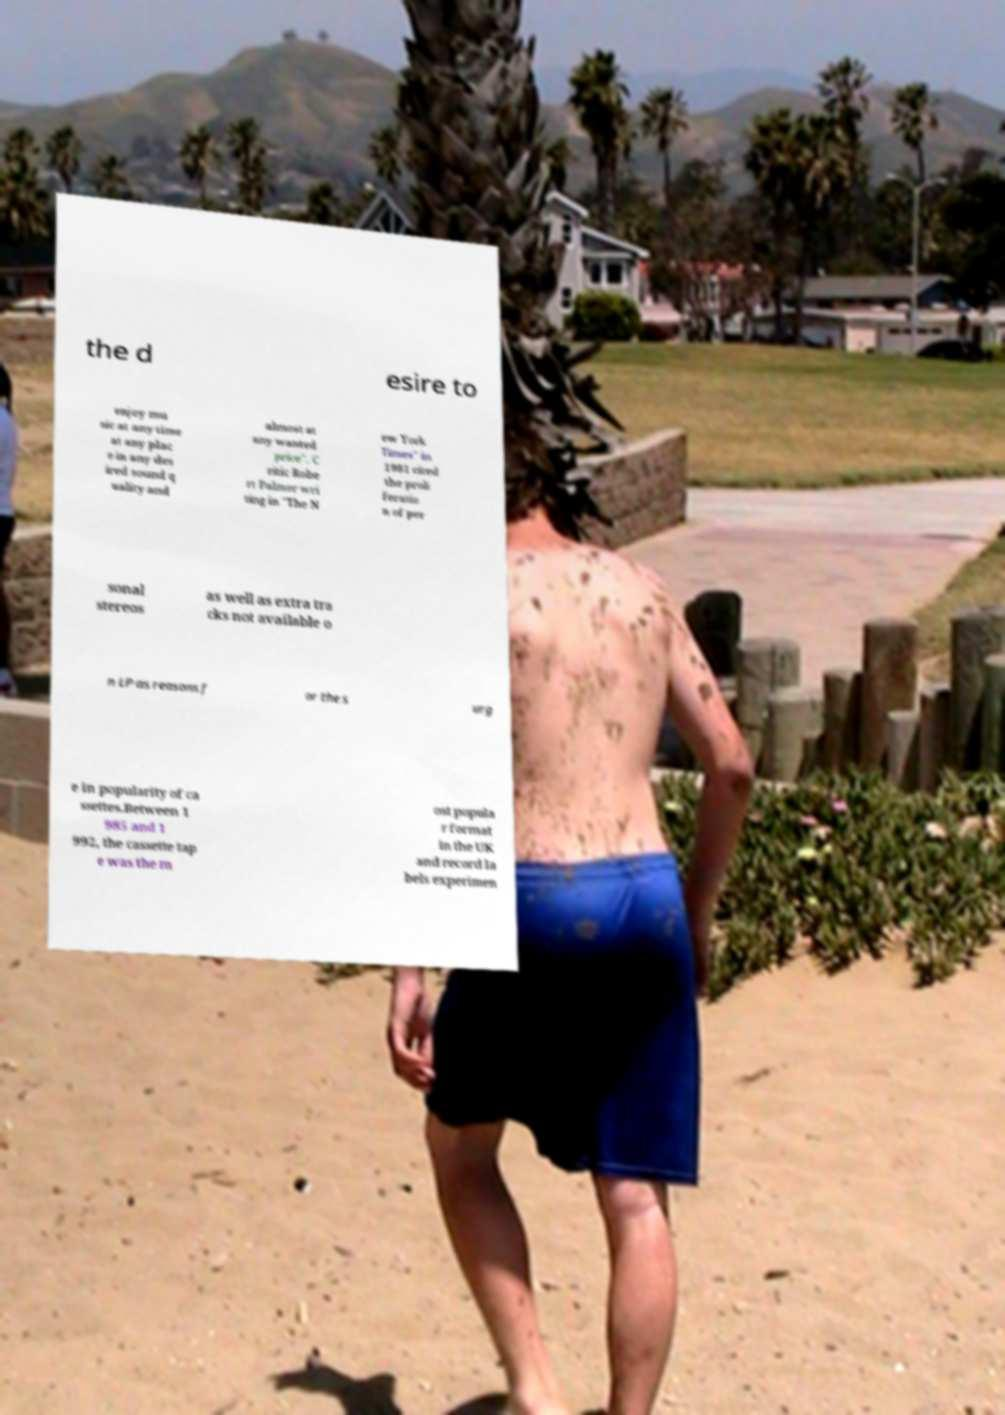What messages or text are displayed in this image? I need them in a readable, typed format. the d esire to enjoy mu sic at any time at any plac e in any des ired sound q uality and almost at any wanted price". C ritic Robe rt Palmer wri ting in "The N ew York Times" in 1981 cited the proli feratio n of per sonal stereos as well as extra tra cks not available o n LP as reasons f or the s urg e in popularity of ca ssettes.Between 1 985 and 1 992, the cassette tap e was the m ost popula r format in the UK and record la bels experimen 